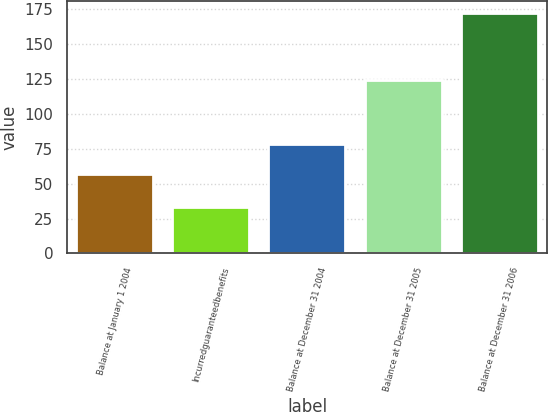<chart> <loc_0><loc_0><loc_500><loc_500><bar_chart><fcel>Balance at January 1 2004<fcel>Incurredguaranteedbenefits<fcel>Balance at December 31 2004<fcel>Balance at December 31 2005<fcel>Balance at December 31 2006<nl><fcel>57<fcel>33<fcel>78<fcel>124<fcel>172<nl></chart> 